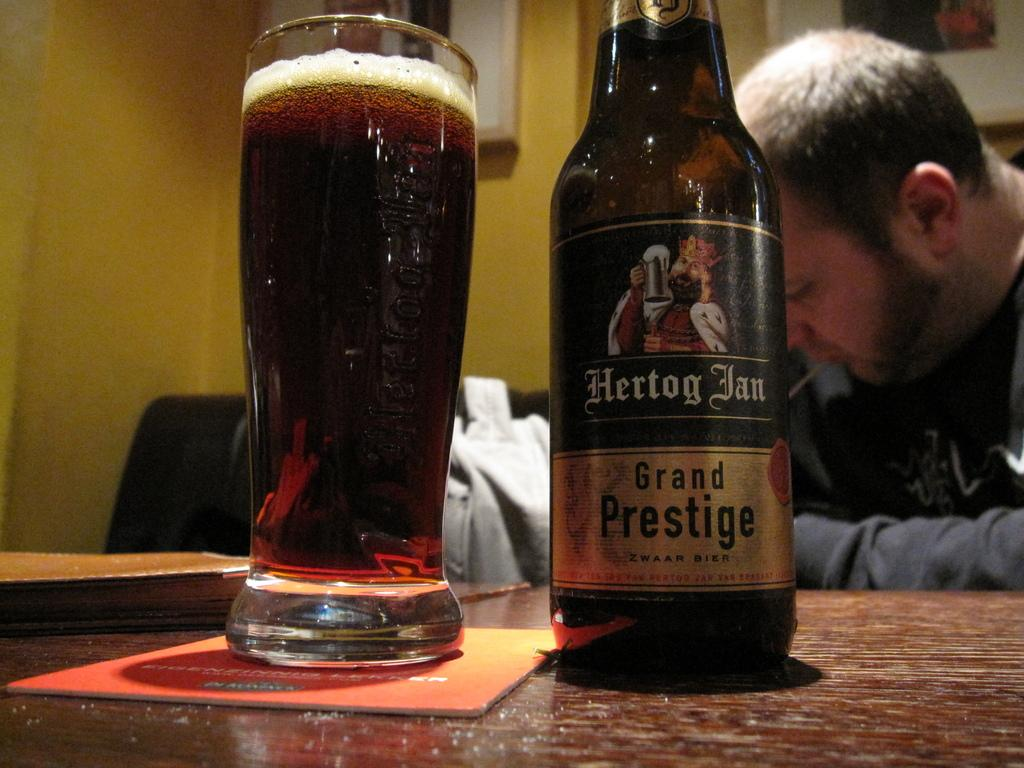<image>
Provide a brief description of the given image. A glass bottle of Hertog Jan next to a drinking glass 